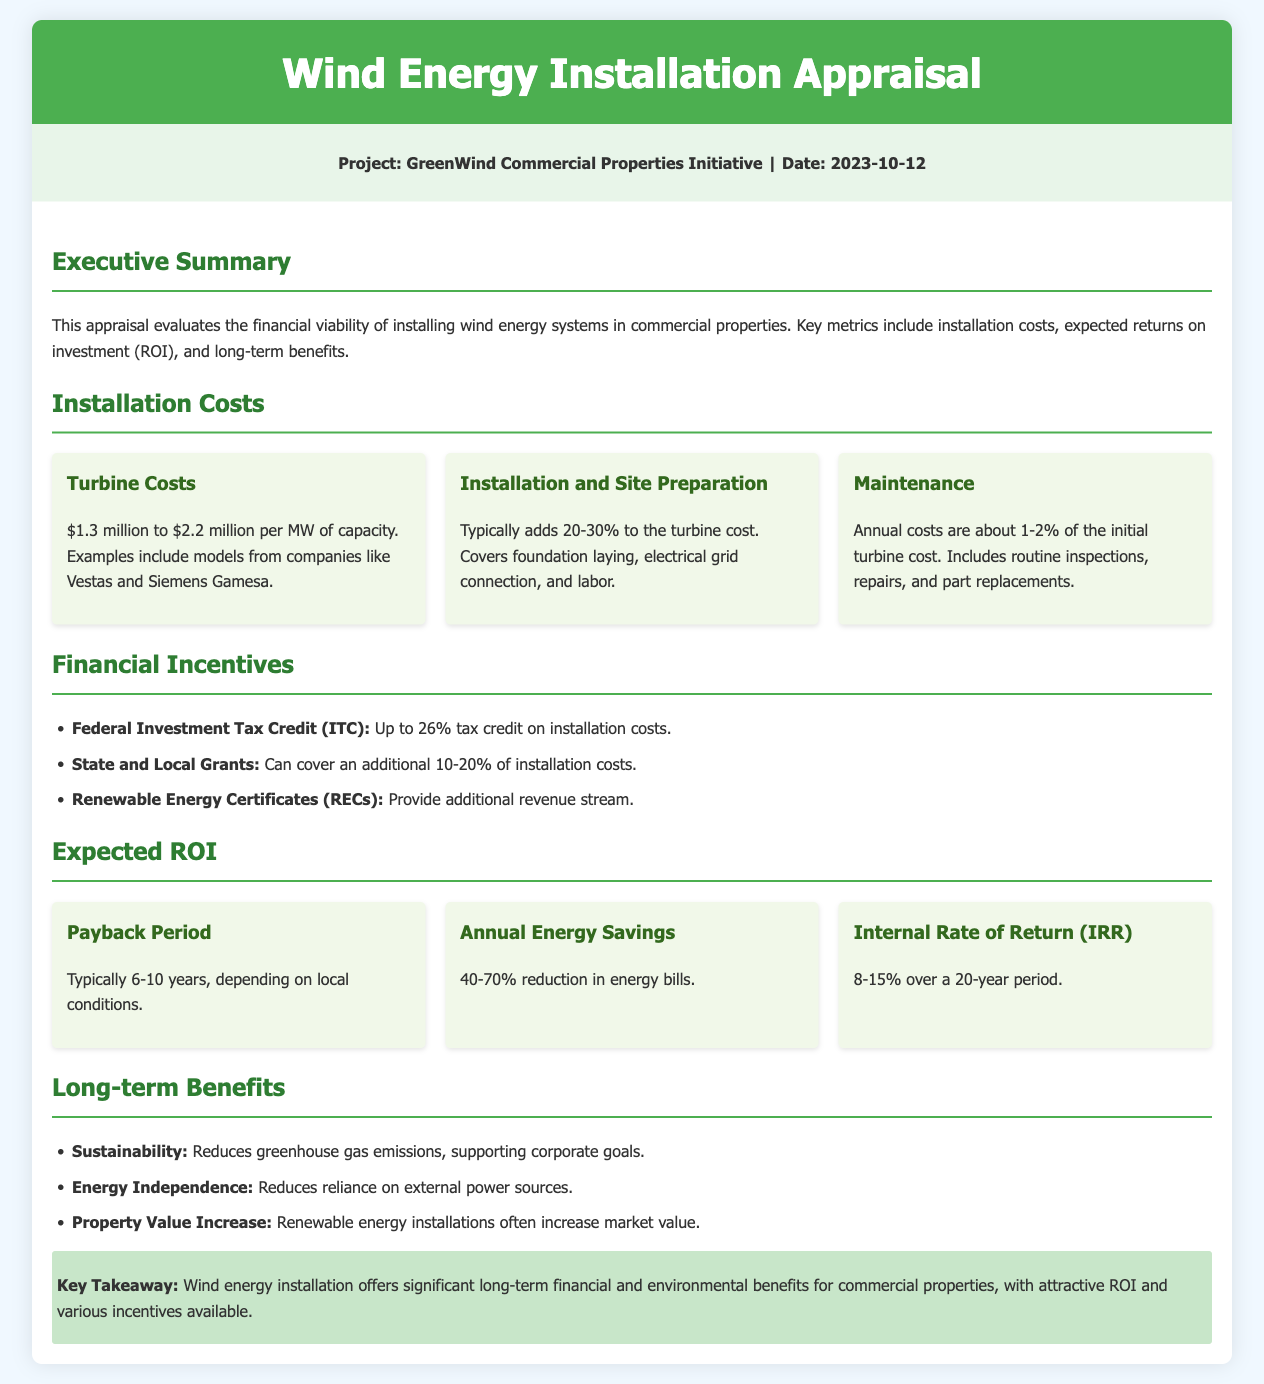What is the project name? The project name is specified in the project info section of the document.
Answer: GreenWind Commercial Properties Initiative What is the date of the appraisal? The date can be found in the project info section of the document.
Answer: 2023-10-12 What is the cost range for turbines per MW? This information is provided under the turbine costs section of the document.
Answer: $1.3 million to $2.2 million What is the annual maintenance cost percentage? The percentage is mentioned in the maintenance section of the document.
Answer: 1-2% What is the expected payback period for installation? The payback period is outlined in the expected ROI section of the document.
Answer: 6-10 years What is the possible Federal ITC tax credit percentage? This figure is provided in the financial incentives section of the document.
Answer: Up to 26% What is the range for expected annual energy savings? The range can be found under the expected ROI section of the document.
Answer: 40-70% What are the long-term benefits mentioned in the document? Multiple benefits are listed in the long-term benefits section. This is a reasoning question since it involves interpreting a list.
Answer: Sustainability, Energy Independence, Property Value Increase What is the internal rate of return (IRR) range over 20 years? This information is provided in the expected ROI section of the document.
Answer: 8-15% 